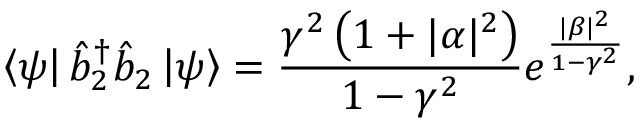Convert formula to latex. <formula><loc_0><loc_0><loc_500><loc_500>\left \langle \psi \right | \hat { b } _ { 2 } ^ { \dagger } \hat { b } _ { 2 } \left | \psi \right \rangle = \frac { \gamma ^ { 2 } \left ( 1 + | \alpha | ^ { 2 } \right ) } { 1 - \gamma ^ { 2 } } e ^ { \frac { | \beta | ^ { 2 } } { 1 - \gamma ^ { 2 } } } ,</formula> 